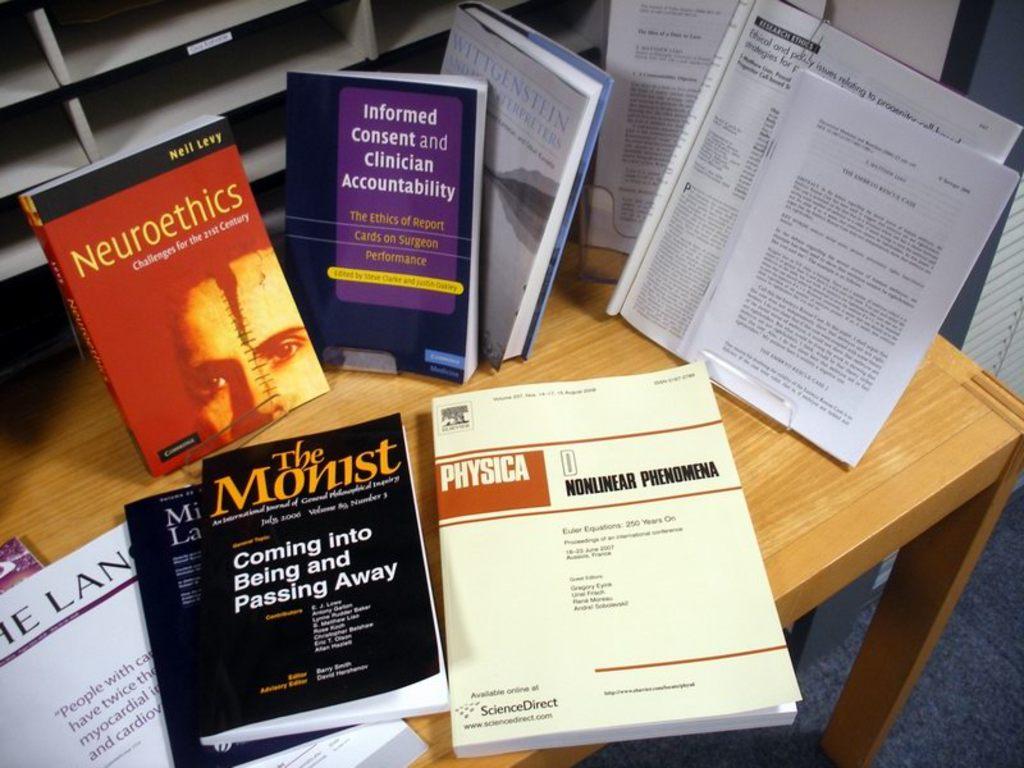Who is the author for neuroethics book?
Provide a short and direct response. Neil levy. 